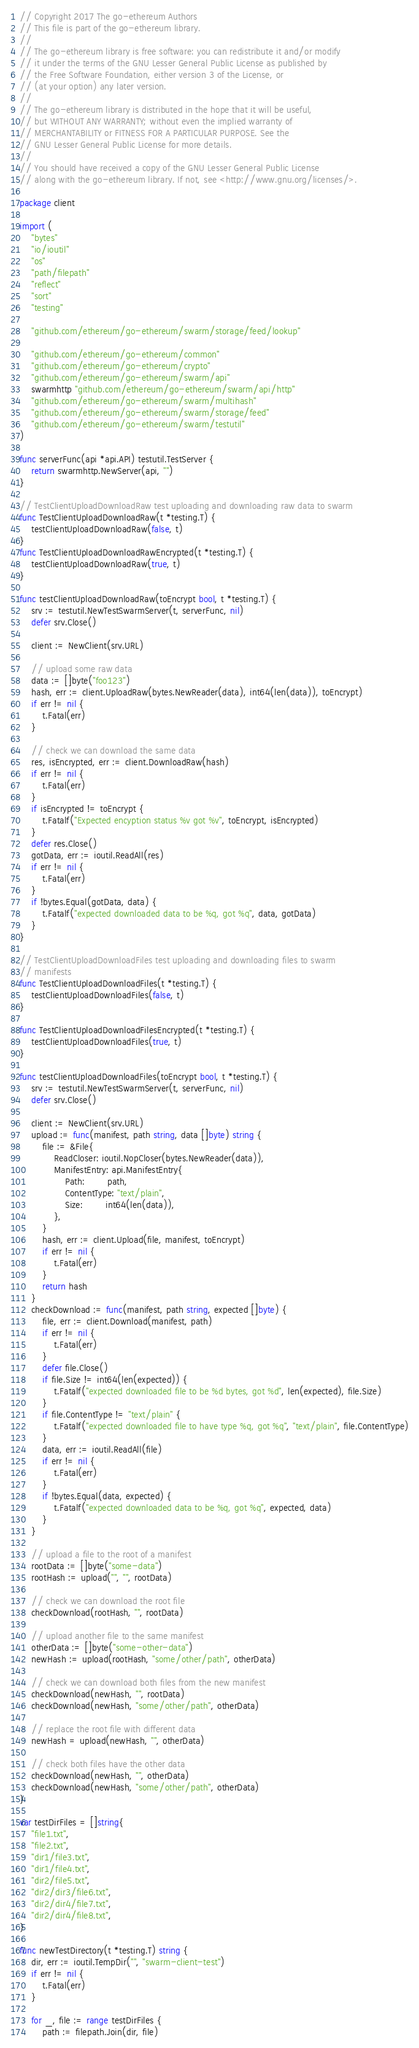Convert code to text. <code><loc_0><loc_0><loc_500><loc_500><_Go_>// Copyright 2017 The go-ethereum Authors
// This file is part of the go-ethereum library.
//
// The go-ethereum library is free software: you can redistribute it and/or modify
// it under the terms of the GNU Lesser General Public License as published by
// the Free Software Foundation, either version 3 of the License, or
// (at your option) any later version.
//
// The go-ethereum library is distributed in the hope that it will be useful,
// but WITHOUT ANY WARRANTY; without even the implied warranty of
// MERCHANTABILITY or FITNESS FOR A PARTICULAR PURPOSE. See the
// GNU Lesser General Public License for more details.
//
// You should have received a copy of the GNU Lesser General Public License
// along with the go-ethereum library. If not, see <http://www.gnu.org/licenses/>.

package client

import (
	"bytes"
	"io/ioutil"
	"os"
	"path/filepath"
	"reflect"
	"sort"
	"testing"

	"github.com/ethereum/go-ethereum/swarm/storage/feed/lookup"

	"github.com/ethereum/go-ethereum/common"
	"github.com/ethereum/go-ethereum/crypto"
	"github.com/ethereum/go-ethereum/swarm/api"
	swarmhttp "github.com/ethereum/go-ethereum/swarm/api/http"
	"github.com/ethereum/go-ethereum/swarm/multihash"
	"github.com/ethereum/go-ethereum/swarm/storage/feed"
	"github.com/ethereum/go-ethereum/swarm/testutil"
)

func serverFunc(api *api.API) testutil.TestServer {
	return swarmhttp.NewServer(api, "")
}

// TestClientUploadDownloadRaw test uploading and downloading raw data to swarm
func TestClientUploadDownloadRaw(t *testing.T) {
	testClientUploadDownloadRaw(false, t)
}
func TestClientUploadDownloadRawEncrypted(t *testing.T) {
	testClientUploadDownloadRaw(true, t)
}

func testClientUploadDownloadRaw(toEncrypt bool, t *testing.T) {
	srv := testutil.NewTestSwarmServer(t, serverFunc, nil)
	defer srv.Close()

	client := NewClient(srv.URL)

	// upload some raw data
	data := []byte("foo123")
	hash, err := client.UploadRaw(bytes.NewReader(data), int64(len(data)), toEncrypt)
	if err != nil {
		t.Fatal(err)
	}

	// check we can download the same data
	res, isEncrypted, err := client.DownloadRaw(hash)
	if err != nil {
		t.Fatal(err)
	}
	if isEncrypted != toEncrypt {
		t.Fatalf("Expected encyption status %v got %v", toEncrypt, isEncrypted)
	}
	defer res.Close()
	gotData, err := ioutil.ReadAll(res)
	if err != nil {
		t.Fatal(err)
	}
	if !bytes.Equal(gotData, data) {
		t.Fatalf("expected downloaded data to be %q, got %q", data, gotData)
	}
}

// TestClientUploadDownloadFiles test uploading and downloading files to swarm
// manifests
func TestClientUploadDownloadFiles(t *testing.T) {
	testClientUploadDownloadFiles(false, t)
}

func TestClientUploadDownloadFilesEncrypted(t *testing.T) {
	testClientUploadDownloadFiles(true, t)
}

func testClientUploadDownloadFiles(toEncrypt bool, t *testing.T) {
	srv := testutil.NewTestSwarmServer(t, serverFunc, nil)
	defer srv.Close()

	client := NewClient(srv.URL)
	upload := func(manifest, path string, data []byte) string {
		file := &File{
			ReadCloser: ioutil.NopCloser(bytes.NewReader(data)),
			ManifestEntry: api.ManifestEntry{
				Path:        path,
				ContentType: "text/plain",
				Size:        int64(len(data)),
			},
		}
		hash, err := client.Upload(file, manifest, toEncrypt)
		if err != nil {
			t.Fatal(err)
		}
		return hash
	}
	checkDownload := func(manifest, path string, expected []byte) {
		file, err := client.Download(manifest, path)
		if err != nil {
			t.Fatal(err)
		}
		defer file.Close()
		if file.Size != int64(len(expected)) {
			t.Fatalf("expected downloaded file to be %d bytes, got %d", len(expected), file.Size)
		}
		if file.ContentType != "text/plain" {
			t.Fatalf("expected downloaded file to have type %q, got %q", "text/plain", file.ContentType)
		}
		data, err := ioutil.ReadAll(file)
		if err != nil {
			t.Fatal(err)
		}
		if !bytes.Equal(data, expected) {
			t.Fatalf("expected downloaded data to be %q, got %q", expected, data)
		}
	}

	// upload a file to the root of a manifest
	rootData := []byte("some-data")
	rootHash := upload("", "", rootData)

	// check we can download the root file
	checkDownload(rootHash, "", rootData)

	// upload another file to the same manifest
	otherData := []byte("some-other-data")
	newHash := upload(rootHash, "some/other/path", otherData)

	// check we can download both files from the new manifest
	checkDownload(newHash, "", rootData)
	checkDownload(newHash, "some/other/path", otherData)

	// replace the root file with different data
	newHash = upload(newHash, "", otherData)

	// check both files have the other data
	checkDownload(newHash, "", otherData)
	checkDownload(newHash, "some/other/path", otherData)
}

var testDirFiles = []string{
	"file1.txt",
	"file2.txt",
	"dir1/file3.txt",
	"dir1/file4.txt",
	"dir2/file5.txt",
	"dir2/dir3/file6.txt",
	"dir2/dir4/file7.txt",
	"dir2/dir4/file8.txt",
}

func newTestDirectory(t *testing.T) string {
	dir, err := ioutil.TempDir("", "swarm-client-test")
	if err != nil {
		t.Fatal(err)
	}

	for _, file := range testDirFiles {
		path := filepath.Join(dir, file)</code> 